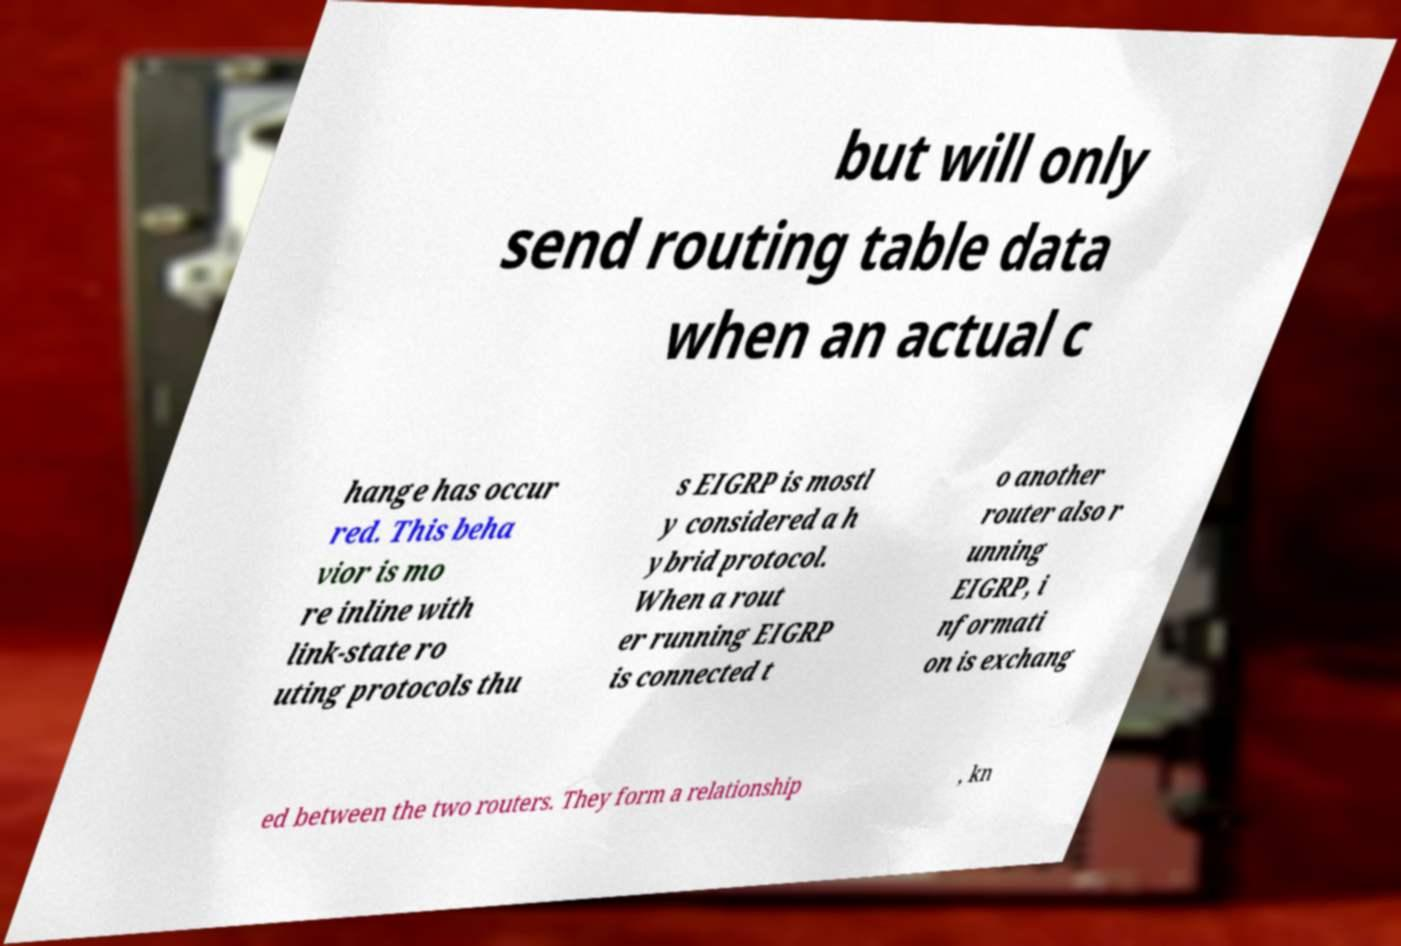I need the written content from this picture converted into text. Can you do that? but will only send routing table data when an actual c hange has occur red. This beha vior is mo re inline with link-state ro uting protocols thu s EIGRP is mostl y considered a h ybrid protocol. When a rout er running EIGRP is connected t o another router also r unning EIGRP, i nformati on is exchang ed between the two routers. They form a relationship , kn 